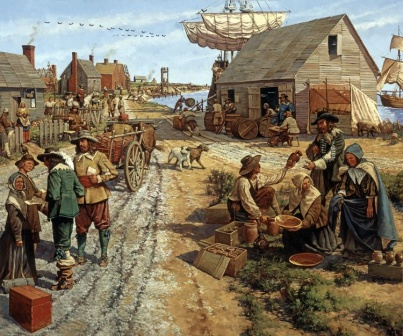Let's get very creative! If this scene were part of a historical fantasy novel, what unique and magical elements might exist in this village? In a historical fantasy novel, this village could be alive with magical elements interwoven with everyday life. The dirt road might glow softly with enchanted cobblestones that light up at night, guiding late travelers. The fruit vendor’s basket could be bottomless, always magically refilling with the freshest produce from an ancient enchanted orchard. The ship at the harbor might have sails woven from mystical fabrics, allowing it to navigate both the waves and the skies, venturing to floating islands and far-off mystical lands. The village would be guarded by a wise, sentient oak tree, its branches providing a sanctuary for mythical creatures and watchful eyes to protect the villagers. Each house could have a protective charm, warding off evil spirits, and the marketplace could hum with the energy of ancient spells, potions, and enchanted artifacts traded alongside everyday goods. 